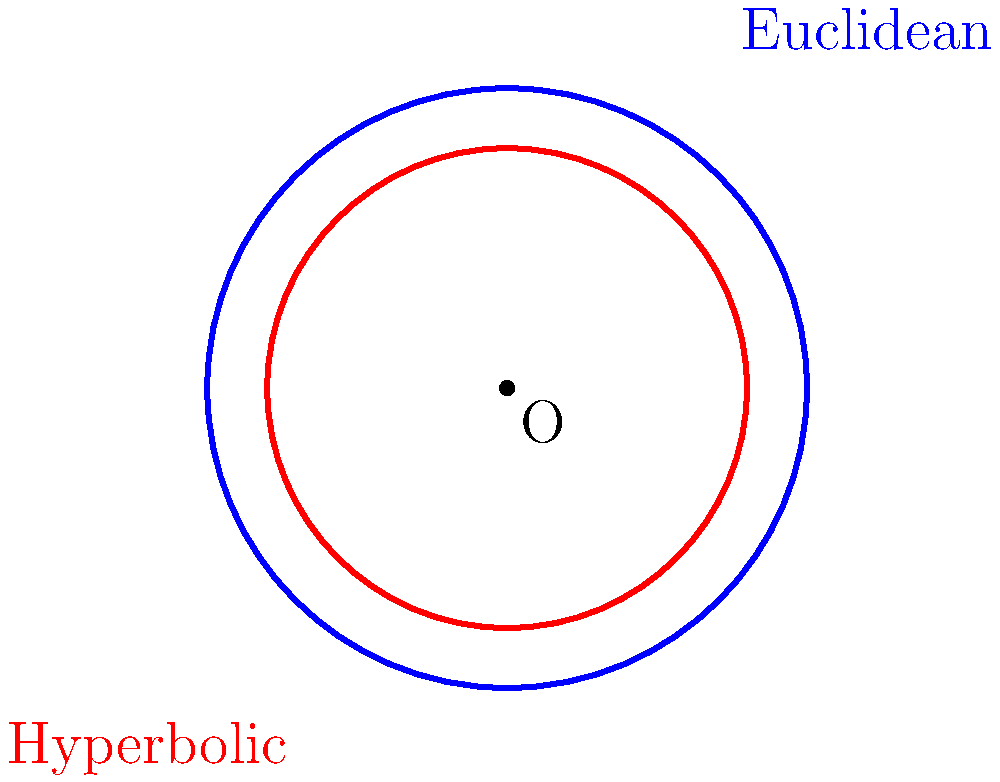As a product manager for the Naptár Modul app, you're exploring innovative ways to visualize calendar data. You come across an interesting mathematical concept comparing circular areas in different geometries. In the diagram, the blue circle represents a Euclidean circle, while the red circle represents its hyperbolic counterpart, both with the same radius $r$. If the area of the Euclidean circle is $A_E = \pi r^2$, and the area of the hyperbolic circle is given by $A_H = 4\pi \sinh^2(\frac{r}{2})$, what is the ratio of the hyperbolic area to the Euclidean area when $r = 2$? Let's approach this step-by-step:

1. We are given that $r = 2$.

2. For the Euclidean circle:
   $A_E = \pi r^2 = \pi (2)^2 = 4\pi$

3. For the hyperbolic circle:
   $A_H = 4\pi \sinh^2(\frac{r}{2}) = 4\pi \sinh^2(1)$

4. We need to calculate $\sinh(1)$:
   $\sinh(1) = \frac{e^1 - e^{-1}}{2} \approx 1.1752$

5. Now we can calculate $A_H$:
   $A_H = 4\pi (1.1752)^2 \approx 17.2824$

6. The ratio of the areas is:
   $\frac{A_H}{A_E} = \frac{17.2824}{4\pi} \approx 1.3788$

This means the hyperbolic circle's area is approximately 1.3788 times larger than the Euclidean circle's area for $r = 2$.
Answer: 1.3788 